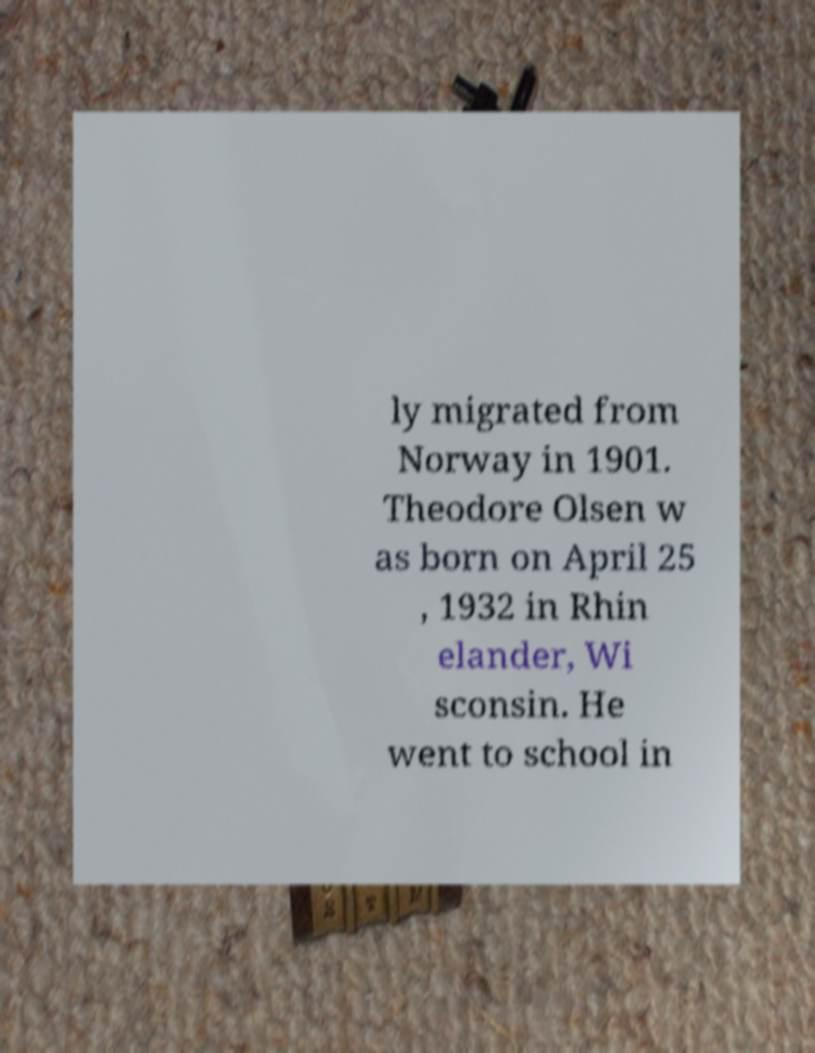Can you read and provide the text displayed in the image?This photo seems to have some interesting text. Can you extract and type it out for me? ly migrated from Norway in 1901. Theodore Olsen w as born on April 25 , 1932 in Rhin elander, Wi sconsin. He went to school in 